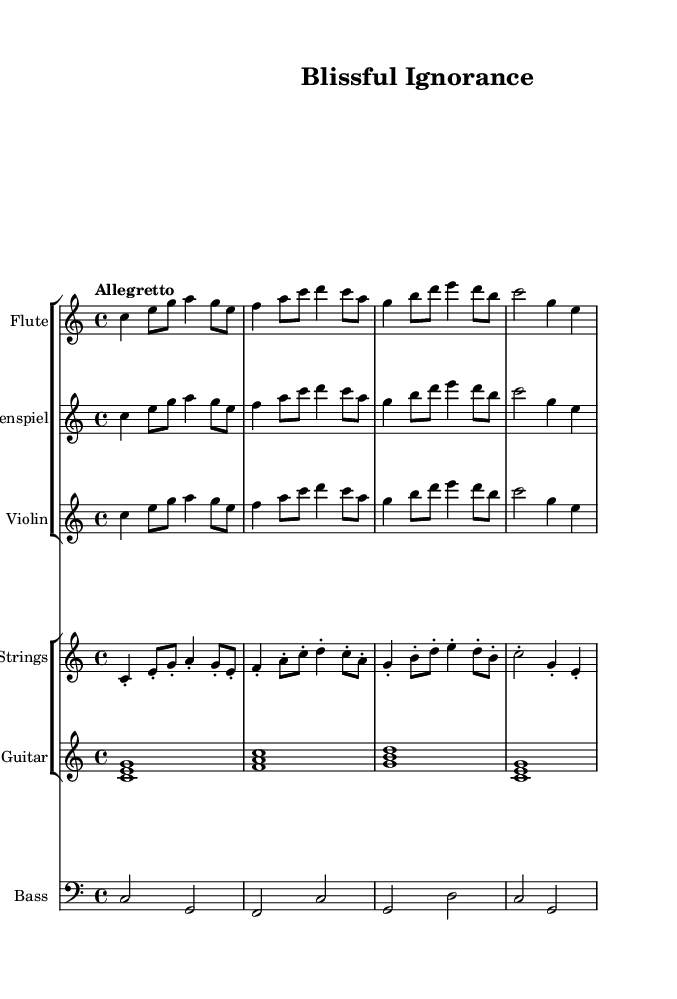What is the key signature of this music? The key signature is indicated at the beginning of the staff, which shows no sharps or flats, confirming it is in C major.
Answer: C major What is the time signature of this music? The time signature appears at the start of the score as 4/4, which indicates four beats per measure.
Answer: 4/4 What is the tempo marking for this piece? The tempo marking is written above the music and states "Allegretto," which suggests a moderately quick pace.
Answer: Allegretto How many instruments are featured in this piece? By counting the separate staves within the score, we see there are six different instruments represented: Flute, Glockenspiel, Violin, Pizz. Strings, Guitar, and Bass.
Answer: Six What is the last note played in the flute part? Looking at the flute staff, the last note is written as a G note and is marked as a quarter note, which is held for one beat.
Answer: G Which instruments play the same melody? By examining the score and looking at the flute, glockenspiel, and violin staves, we notice they all share the same melodic line throughout the piece.
Answer: Flute, Glockenspiel, Violin What is the rhythmic pattern of the pizzicato part in the first measure? In the first measure of the pizzicato part, the rhythm consists of a quarter note followed by an eighth note, two sixteenth notes, and a quarter note, creating a playful and uplifting rhythm.
Answer: Quarter, Eighth, Sixteenth, Quarter 